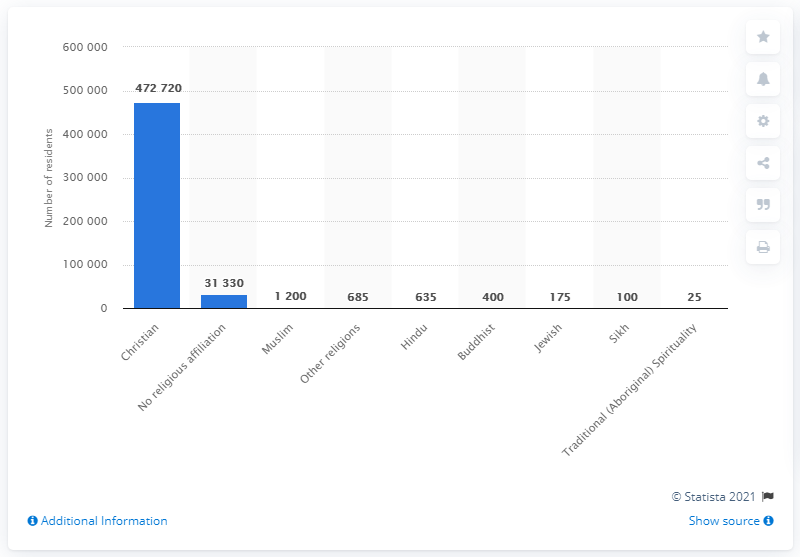Specify some key components in this picture. The majority of residents in Newfoundland and Labrador in 2011 were identified as Christian. 